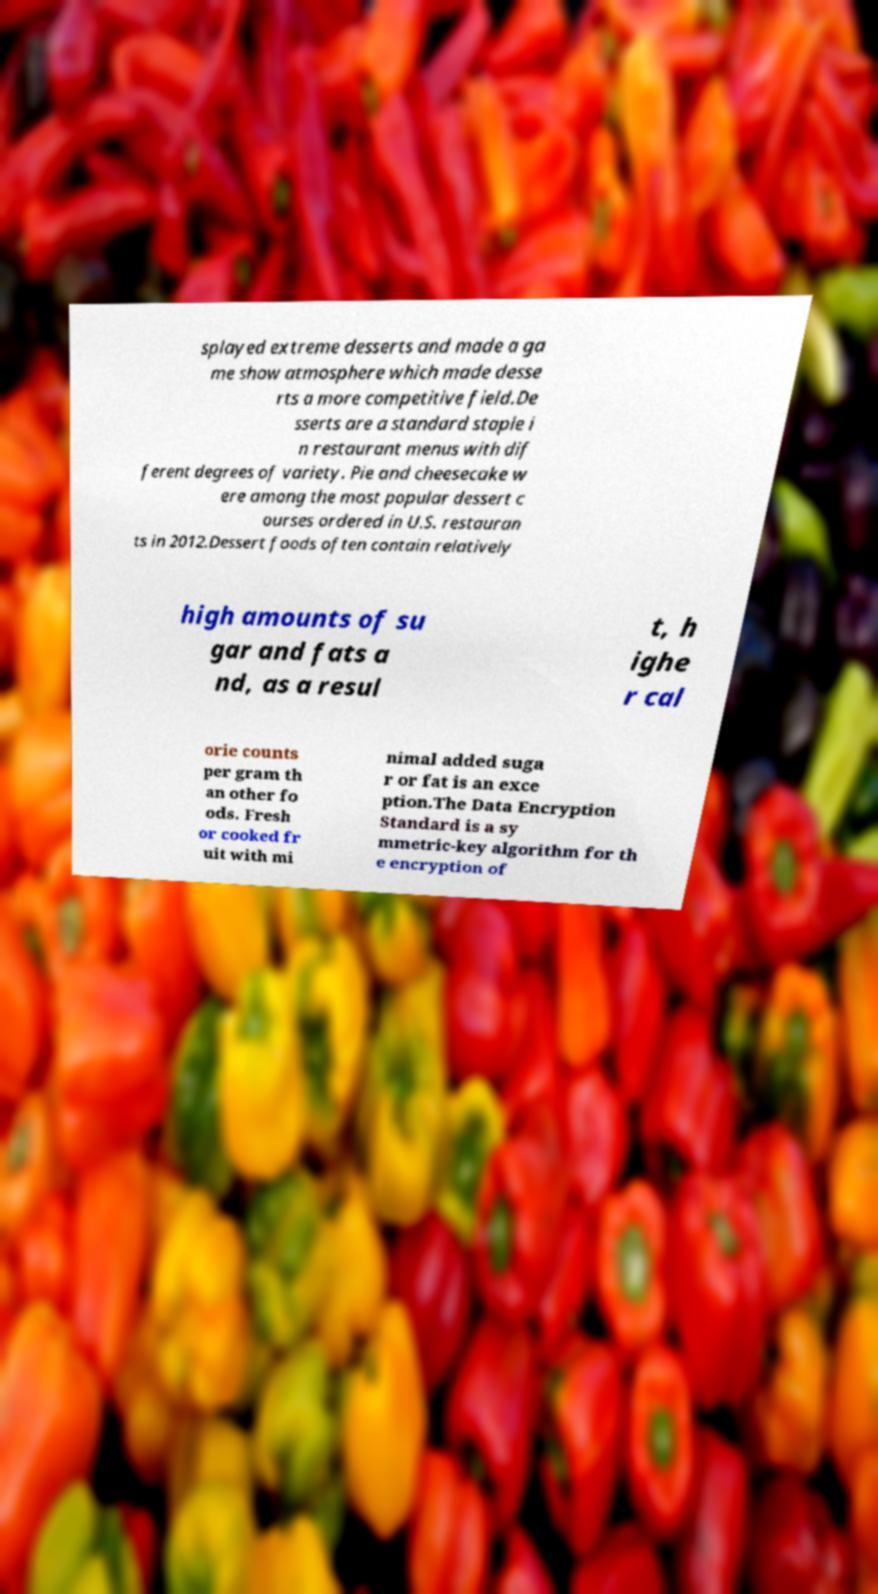Can you read and provide the text displayed in the image?This photo seems to have some interesting text. Can you extract and type it out for me? splayed extreme desserts and made a ga me show atmosphere which made desse rts a more competitive field.De sserts are a standard staple i n restaurant menus with dif ferent degrees of variety. Pie and cheesecake w ere among the most popular dessert c ourses ordered in U.S. restauran ts in 2012.Dessert foods often contain relatively high amounts of su gar and fats a nd, as a resul t, h ighe r cal orie counts per gram th an other fo ods. Fresh or cooked fr uit with mi nimal added suga r or fat is an exce ption.The Data Encryption Standard is a sy mmetric-key algorithm for th e encryption of 